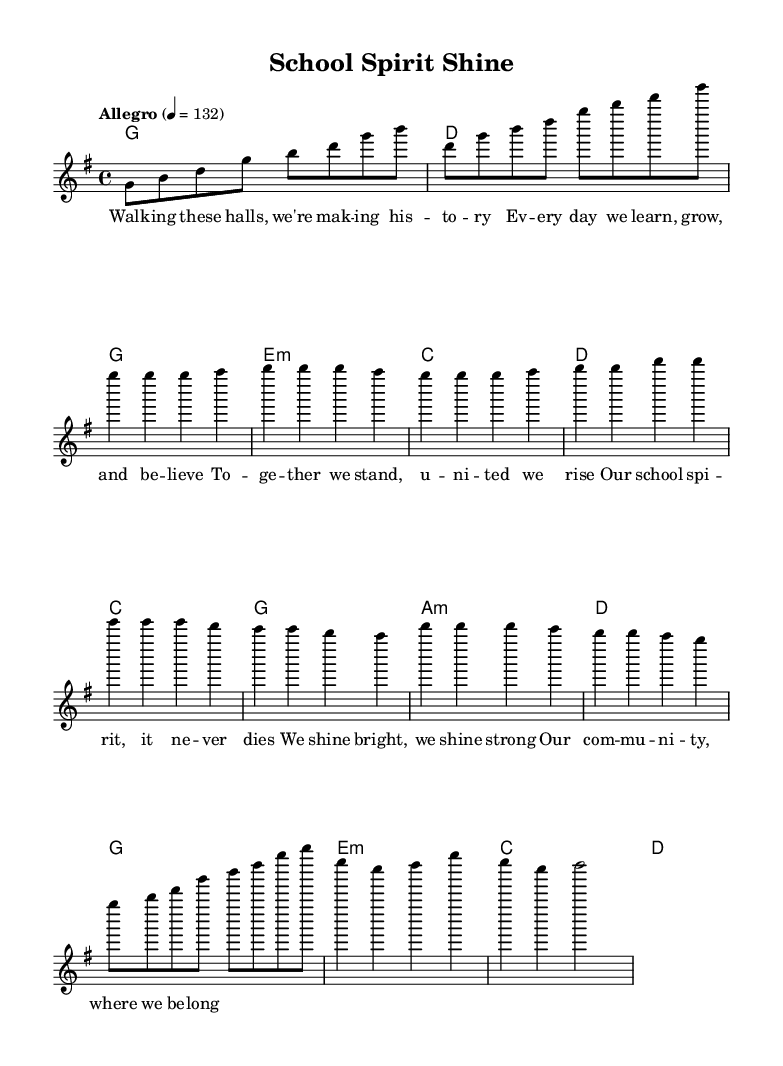What is the key signature of this music? The key signature is G major, which has one sharp (F sharp).
Answer: G major What is the time signature of this music? The time signature is 4/4, indicating four beats in each measure.
Answer: 4/4 What is the tempo marking of this piece? The tempo marking is "Allegro" with a metronome marking of 132 beats per minute.
Answer: Allegro How many measures are in the chorus section? The chorus consists of three measures, as indicated by the notes written under that section.
Answer: Three measures Which musical mode is used in the harmonies? The predominant harmonic structure follows a chord mode, which is indicated by the chord names in the score.
Answer: Chord mode What themes are celebrated in the lyrics of this K-Pop track? The lyrics celebrate school spirit and community involvement, reflecting unity and pride in one's school.
Answer: School spirit and community involvement How does the structure of this track compare to typical K-Pop songs? The structure consists of an intro, verse, pre-chorus, and chorus, which is common in K-Pop with a focus on catchy melodies and themes of youth.
Answer: Intro, verse, pre-chorus, and chorus 